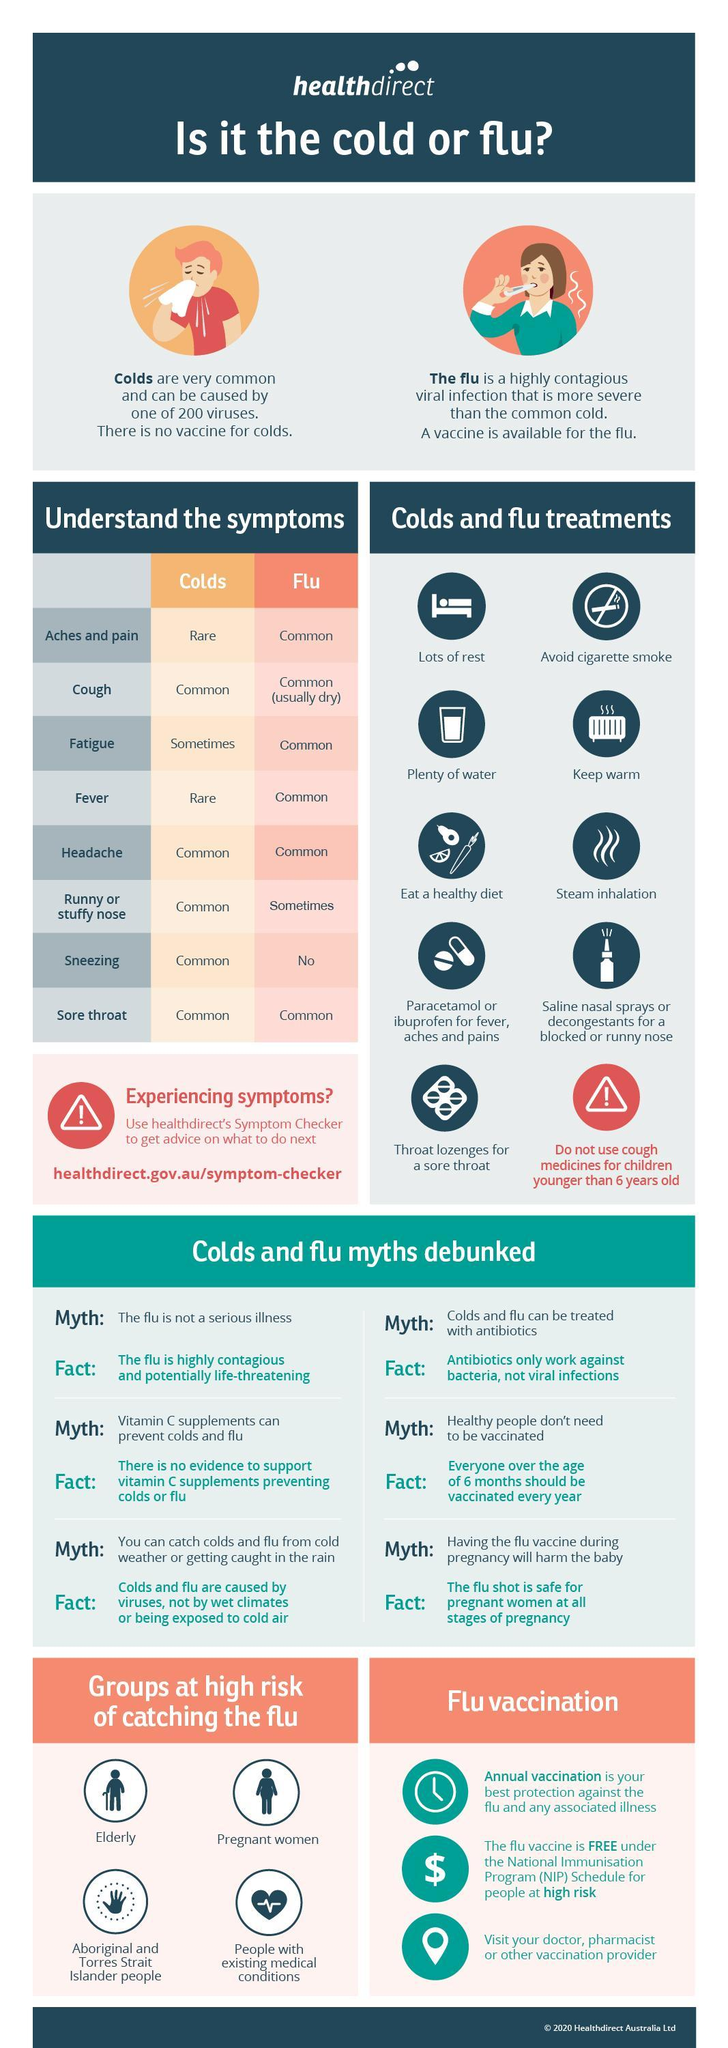How many symptoms are common for flu?
Answer the question with a short phrase. 6 How many symptoms are rare for cold? 2 Which all symptoms are rare for cold? Aches and pain, Fever How many groups are at high risk of catching flu? 4 How many symptoms are common for cold? 5 